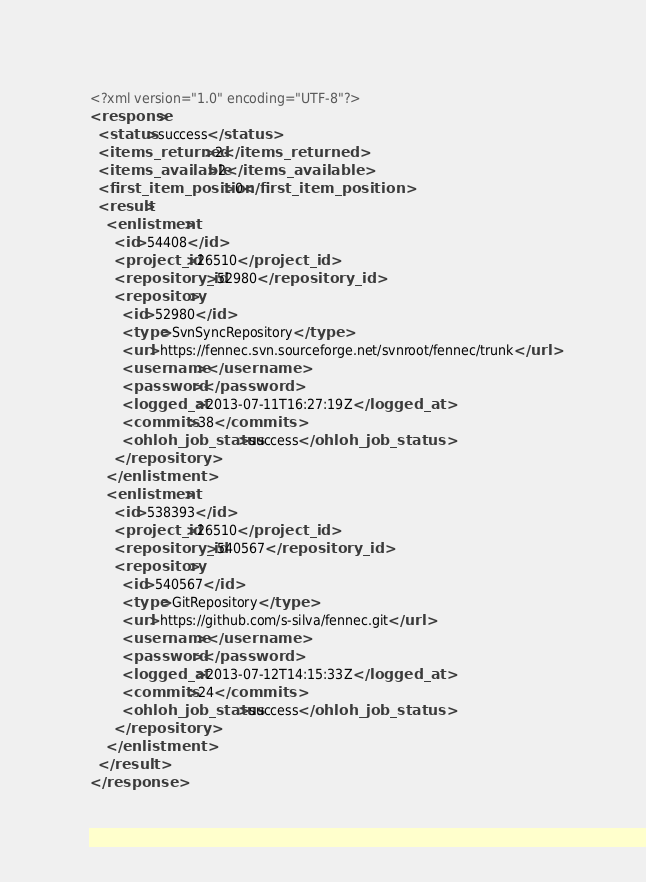Convert code to text. <code><loc_0><loc_0><loc_500><loc_500><_XML_><?xml version="1.0" encoding="UTF-8"?>
<response>
  <status>success</status>
  <items_returned>2</items_returned>
  <items_available>2</items_available>
  <first_item_position>0</first_item_position>
  <result>
    <enlistment>
      <id>54408</id>
      <project_id>26510</project_id>
      <repository_id>52980</repository_id>
      <repository>
        <id>52980</id>
        <type>SvnSyncRepository</type>
        <url>https://fennec.svn.sourceforge.net/svnroot/fennec/trunk</url>
        <username></username>
        <password></password>
        <logged_at>2013-07-11T16:27:19Z</logged_at>
        <commits>38</commits>
        <ohloh_job_status>success</ohloh_job_status>
      </repository>
    </enlistment>
    <enlistment>
      <id>538393</id>
      <project_id>26510</project_id>
      <repository_id>540567</repository_id>
      <repository>
        <id>540567</id>
        <type>GitRepository</type>
        <url>https://github.com/s-silva/fennec.git</url>
        <username></username>
        <password></password>
        <logged_at>2013-07-12T14:15:33Z</logged_at>
        <commits>24</commits>
        <ohloh_job_status>success</ohloh_job_status>
      </repository>
    </enlistment>
  </result>
</response>
</code> 